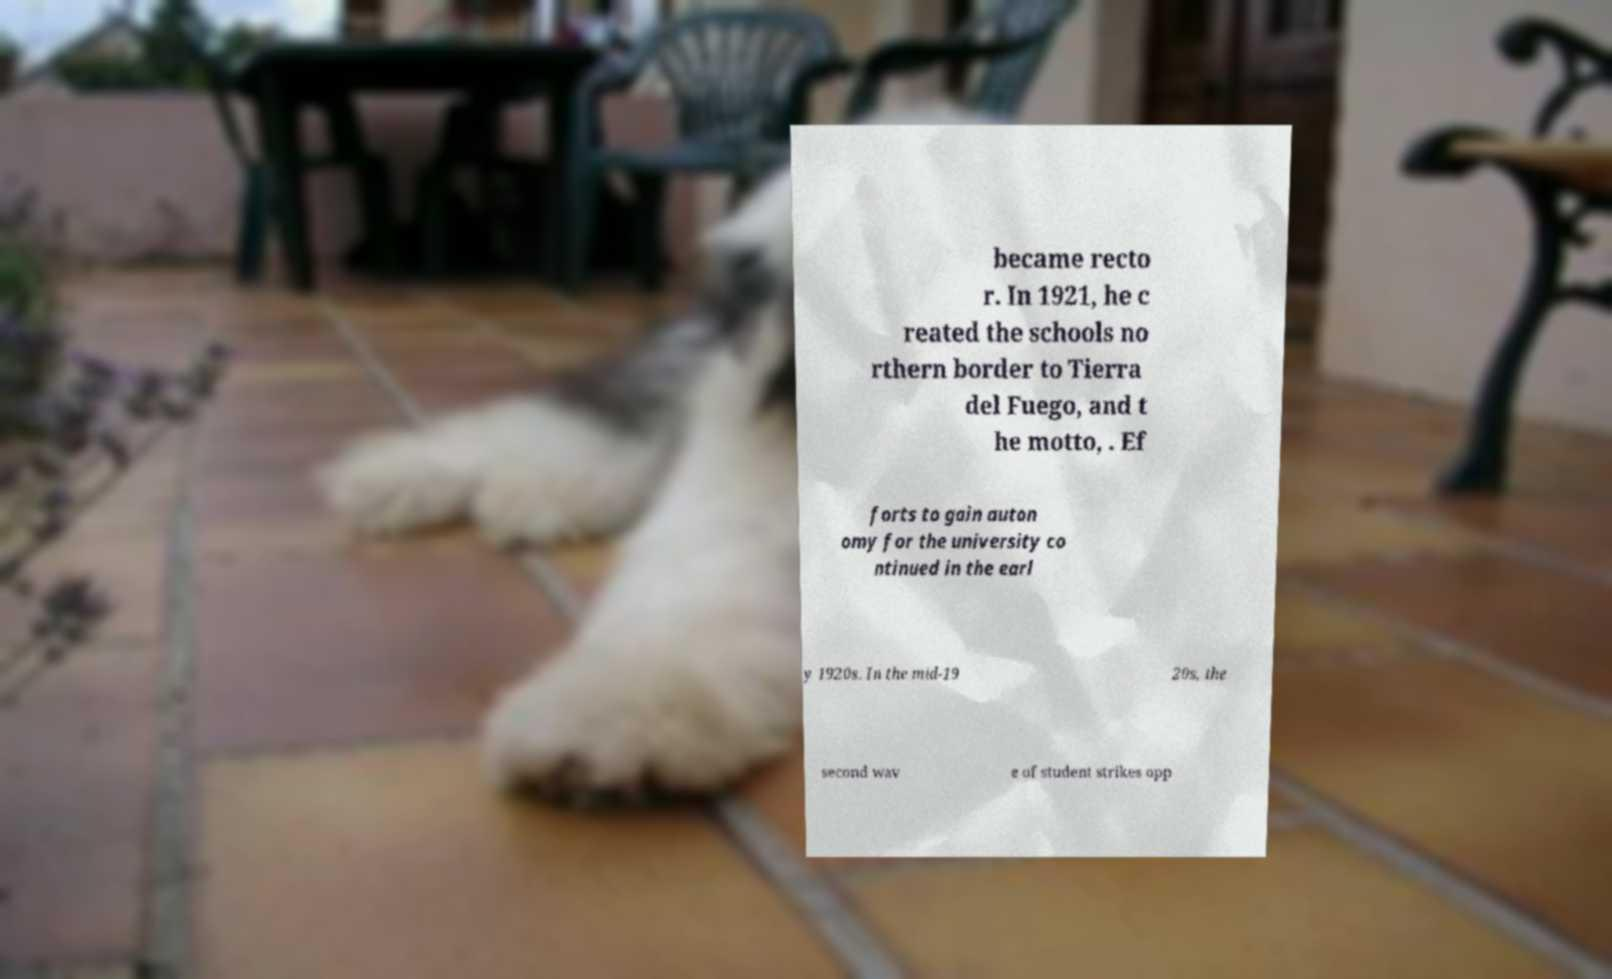What messages or text are displayed in this image? I need them in a readable, typed format. became recto r. In 1921, he c reated the schools no rthern border to Tierra del Fuego, and t he motto, . Ef forts to gain auton omy for the university co ntinued in the earl y 1920s. In the mid-19 20s, the second wav e of student strikes opp 